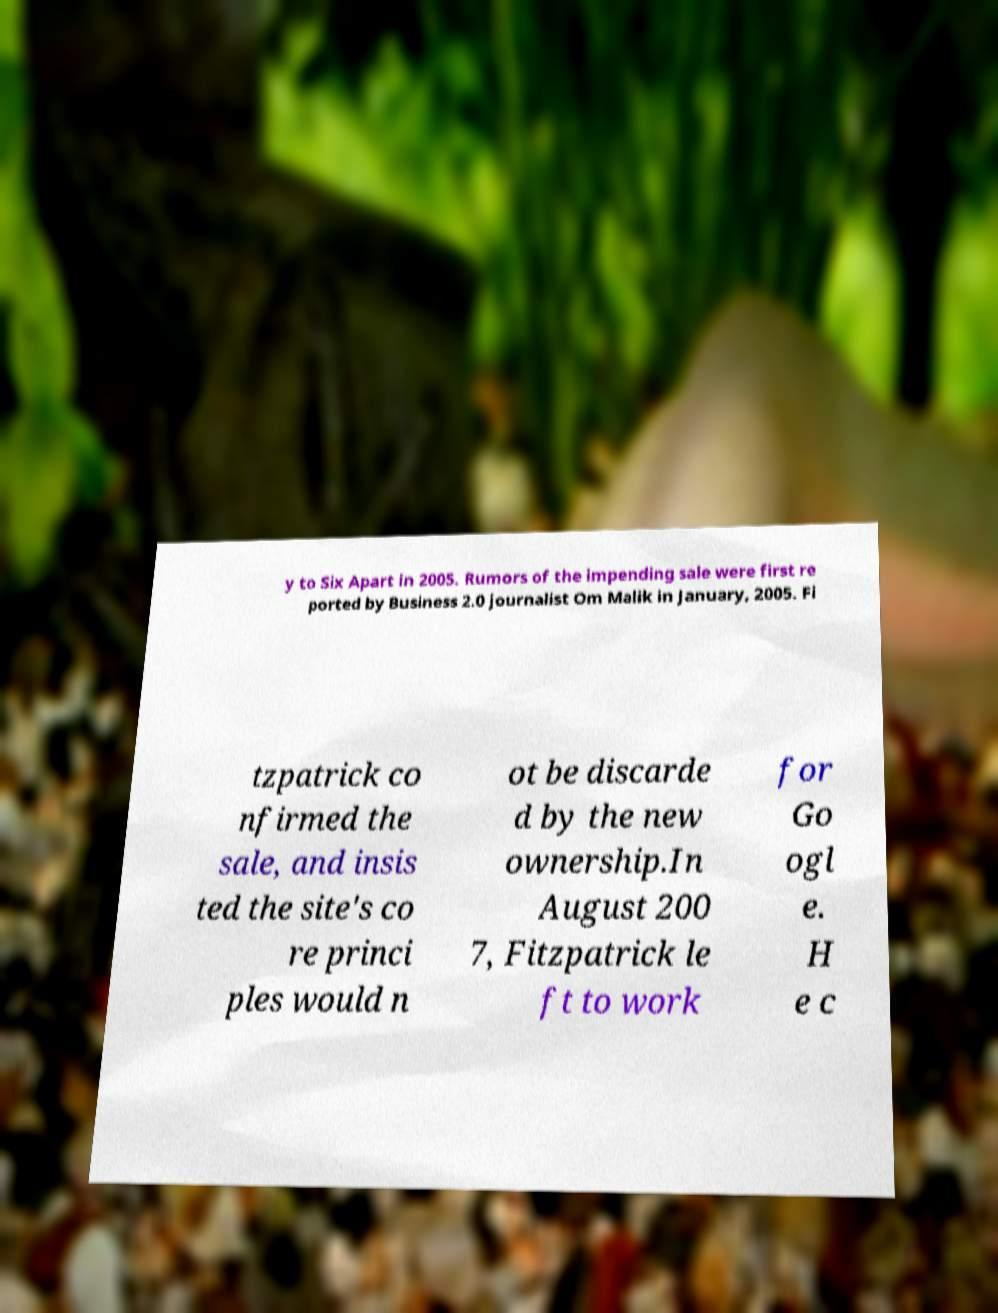Please read and relay the text visible in this image. What does it say? y to Six Apart in 2005. Rumors of the impending sale were first re ported by Business 2.0 journalist Om Malik in January, 2005. Fi tzpatrick co nfirmed the sale, and insis ted the site's co re princi ples would n ot be discarde d by the new ownership.In August 200 7, Fitzpatrick le ft to work for Go ogl e. H e c 